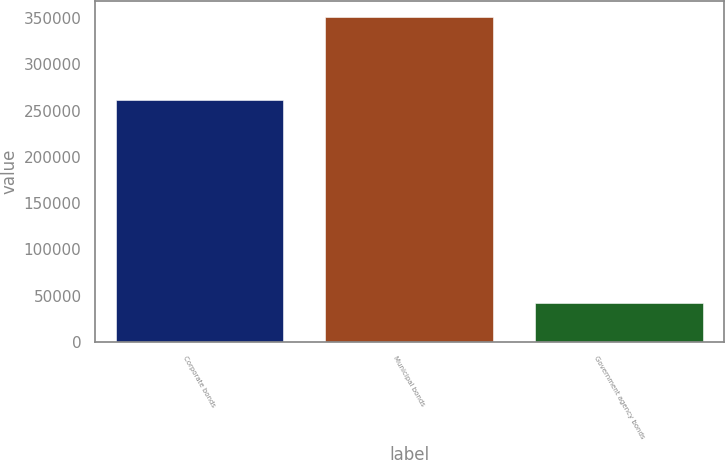Convert chart to OTSL. <chart><loc_0><loc_0><loc_500><loc_500><bar_chart><fcel>Corporate bonds<fcel>Municipal bonds<fcel>Government agency bonds<nl><fcel>261521<fcel>350992<fcel>42409<nl></chart> 